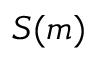Convert formula to latex. <formula><loc_0><loc_0><loc_500><loc_500>S ( m )</formula> 